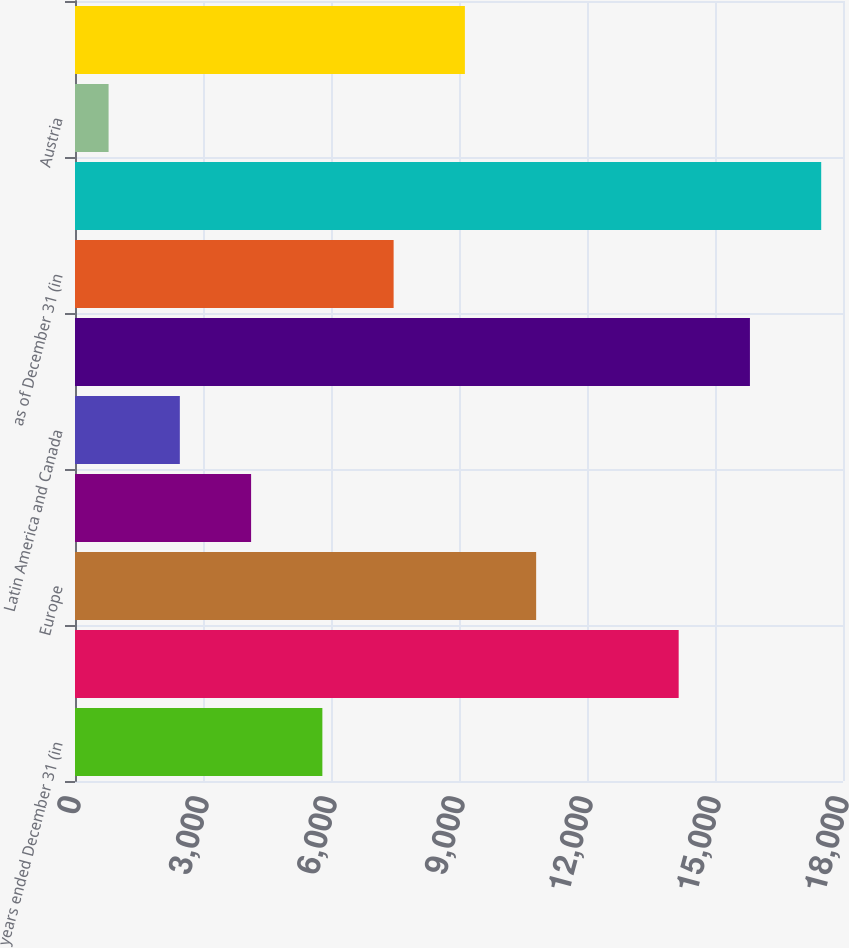Convert chart to OTSL. <chart><loc_0><loc_0><loc_500><loc_500><bar_chart><fcel>years ended December 31 (in<fcel>United States<fcel>Europe<fcel>Asia-Pacific<fcel>Latin America and Canada<fcel>Consolidated net sales<fcel>as of December 31 (in<fcel>Consolidated total assets<fcel>Austria<fcel>Other countries<nl><fcel>5797.6<fcel>14148.6<fcel>10808.2<fcel>4127.4<fcel>2457.2<fcel>15818.8<fcel>7467.8<fcel>17489<fcel>787<fcel>9138<nl></chart> 